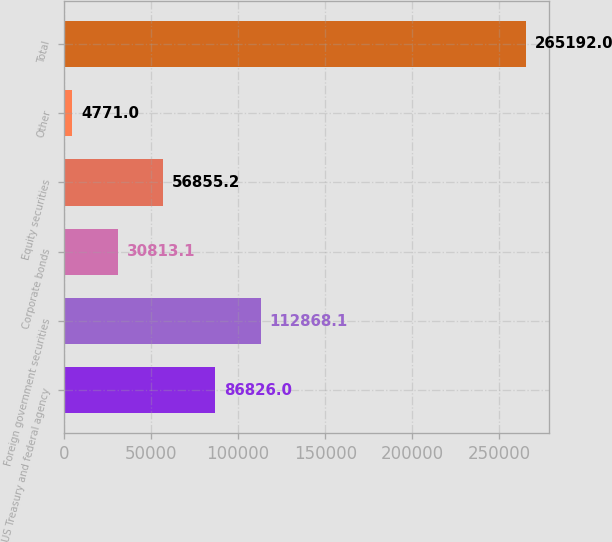Convert chart. <chart><loc_0><loc_0><loc_500><loc_500><bar_chart><fcel>US Treasury and federal agency<fcel>Foreign government securities<fcel>Corporate bonds<fcel>Equity securities<fcel>Other<fcel>Total<nl><fcel>86826<fcel>112868<fcel>30813.1<fcel>56855.2<fcel>4771<fcel>265192<nl></chart> 